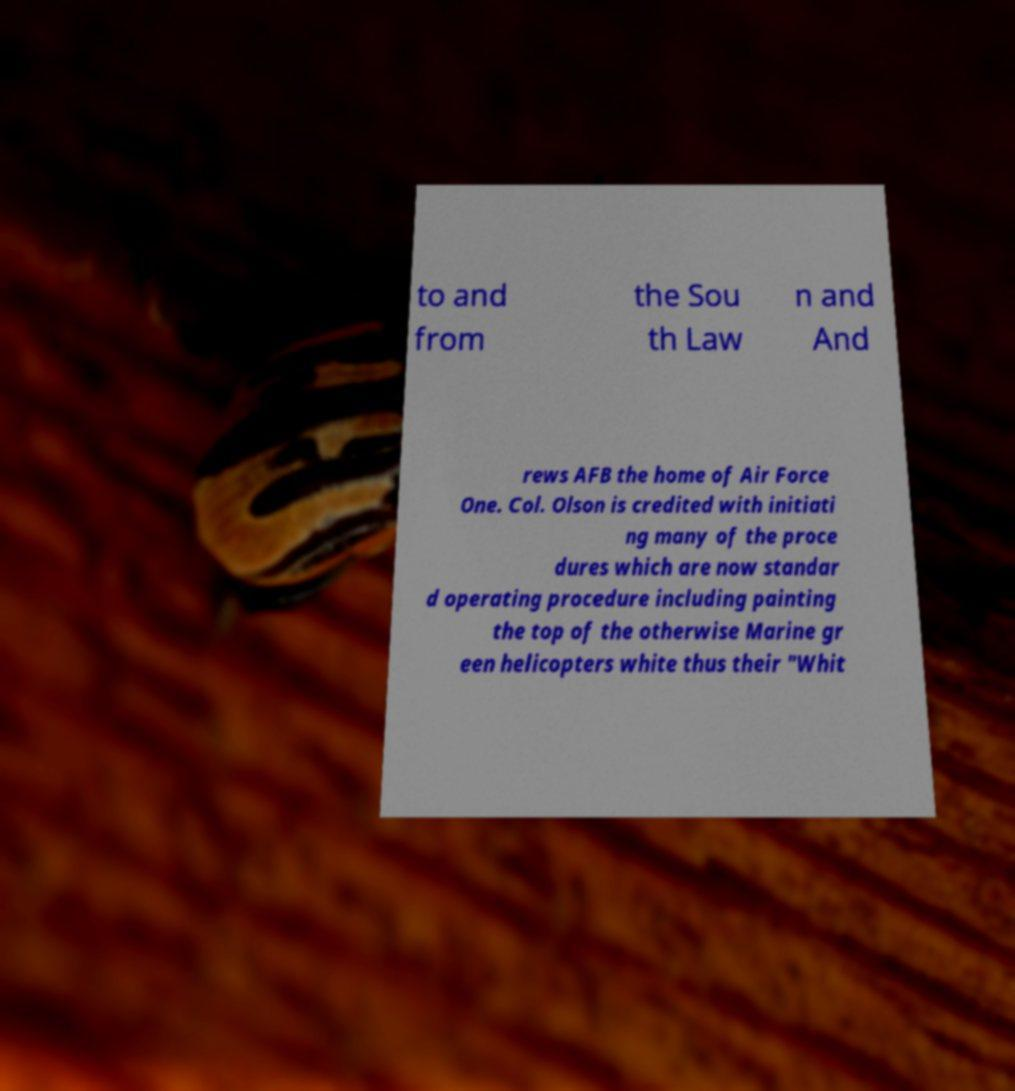Could you assist in decoding the text presented in this image and type it out clearly? to and from the Sou th Law n and And rews AFB the home of Air Force One. Col. Olson is credited with initiati ng many of the proce dures which are now standar d operating procedure including painting the top of the otherwise Marine gr een helicopters white thus their "Whit 